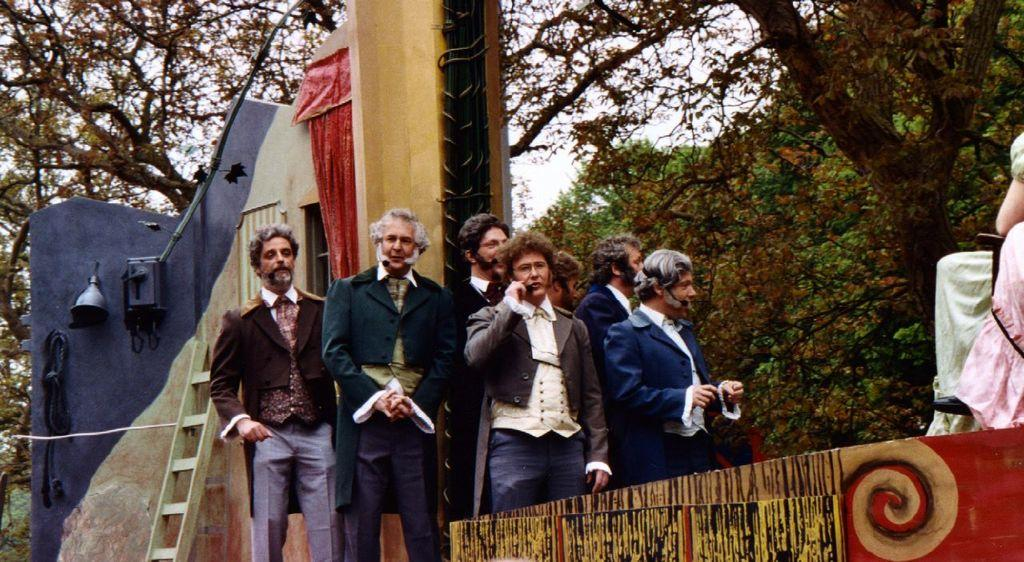How many people are in the image? There is a group of people in the image, but the exact number cannot be determined from the provided facts. What structures or objects can be seen in the image? There is a fence, a ladder, a wall, a window, a curtain, and a bell in the image. What is the background of the image? There are trees and sky visible in the background of the image. What might be used to climb or reach higher in the image? The ladder in the image could be used for climbing or reaching higher. What is associated with the window in the image? There is a curtain associated with the window in the image. How many times do the people in the image smile? The provided facts do not mention the expressions of the people in the image, so it is impossible to determine how many times they smile. What type of flooring is visible in the image? The provided facts do not mention any flooring in the image, so it is impossible to determine its type. 